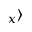<formula> <loc_0><loc_0><loc_500><loc_500>_ { x } \rangle</formula> 